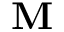<formula> <loc_0><loc_0><loc_500><loc_500>M</formula> 